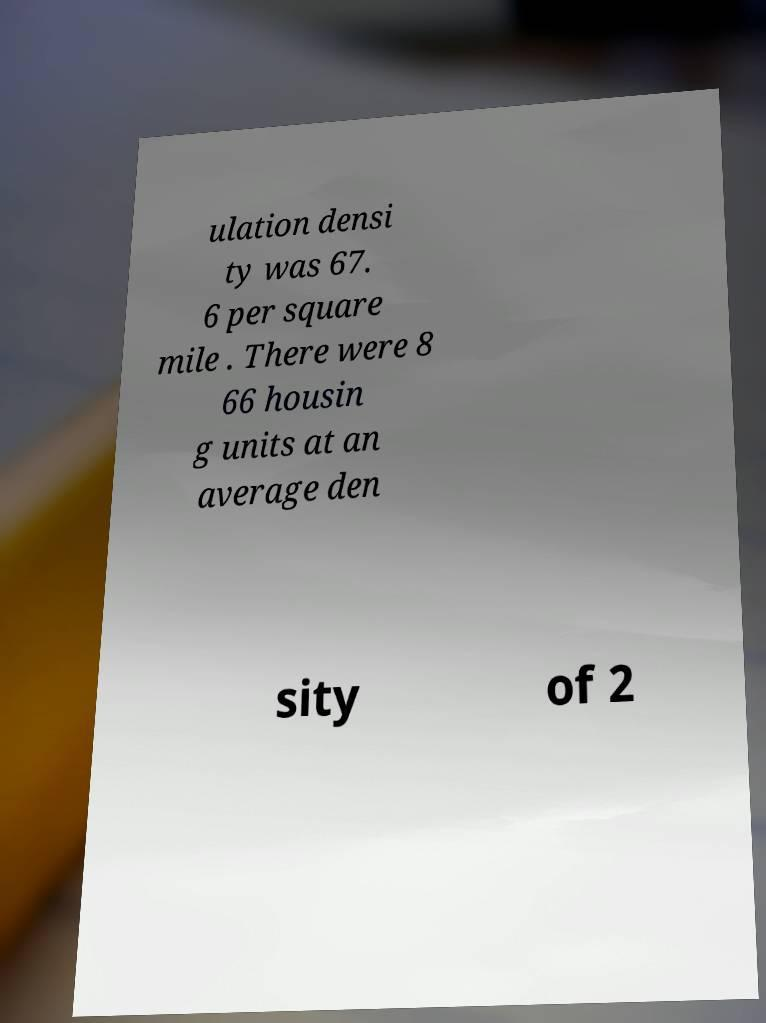Can you accurately transcribe the text from the provided image for me? ulation densi ty was 67. 6 per square mile . There were 8 66 housin g units at an average den sity of 2 